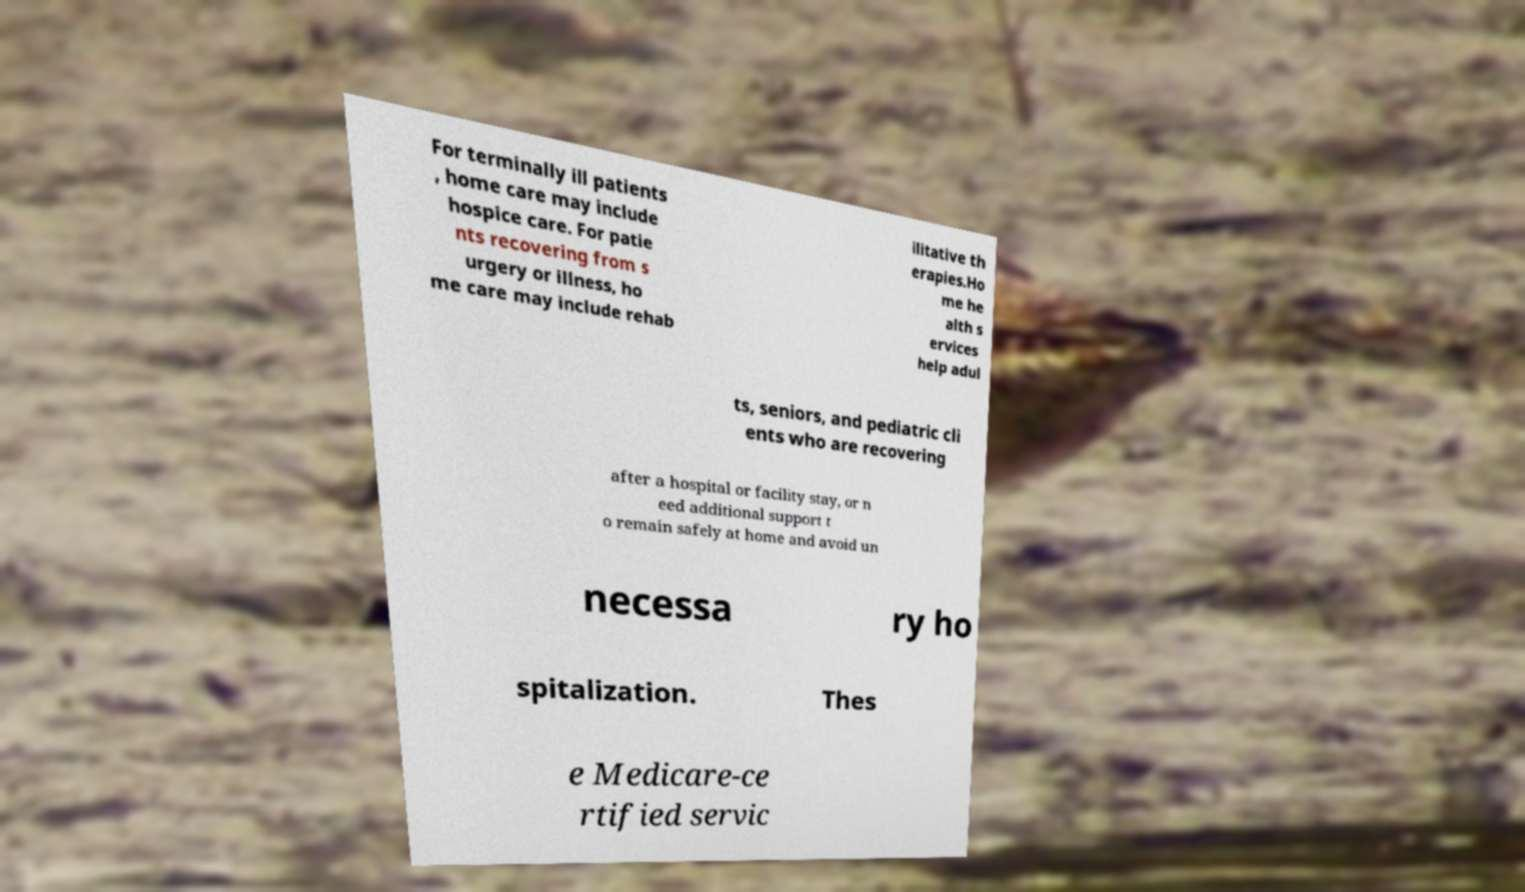Could you extract and type out the text from this image? For terminally ill patients , home care may include hospice care. For patie nts recovering from s urgery or illness, ho me care may include rehab ilitative th erapies.Ho me he alth s ervices help adul ts, seniors, and pediatric cli ents who are recovering after a hospital or facility stay, or n eed additional support t o remain safely at home and avoid un necessa ry ho spitalization. Thes e Medicare-ce rtified servic 